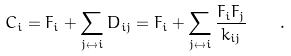Convert formula to latex. <formula><loc_0><loc_0><loc_500><loc_500>C _ { i } = F _ { i } + \sum _ { j \leftrightarrow i } D _ { i j } = F _ { i } + \sum _ { j \leftrightarrow i } \frac { F _ { i } F _ { j } } { k _ { i j } } \quad .</formula> 